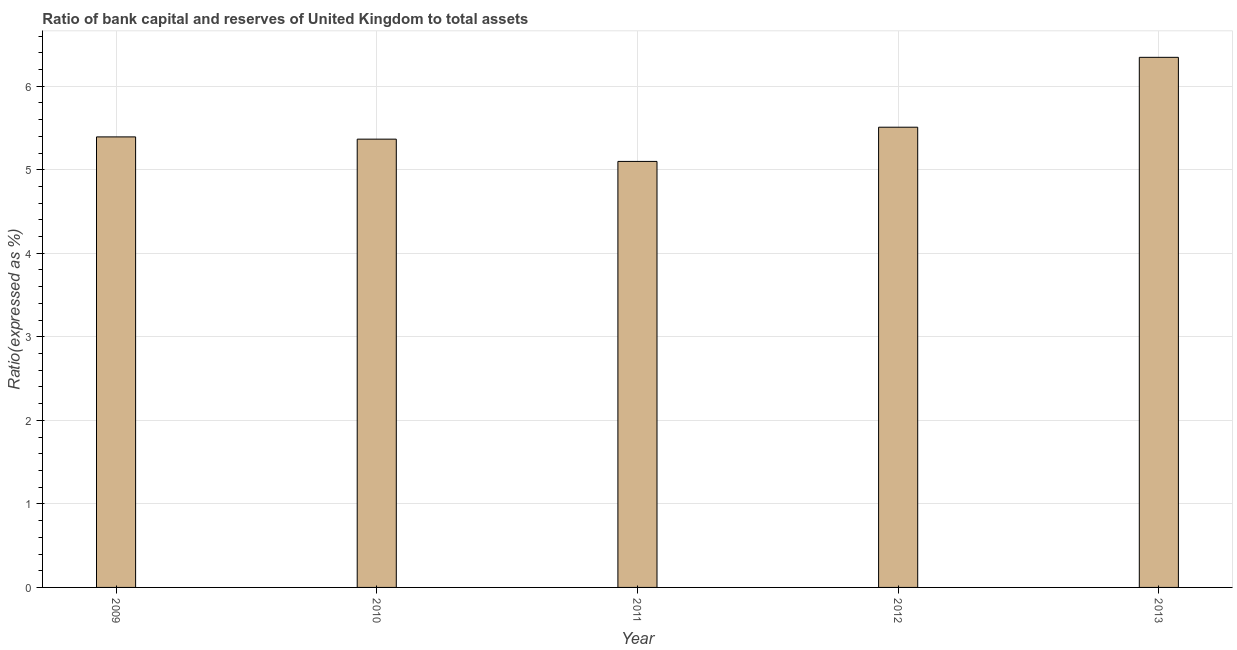What is the title of the graph?
Offer a very short reply. Ratio of bank capital and reserves of United Kingdom to total assets. What is the label or title of the Y-axis?
Provide a succinct answer. Ratio(expressed as %). What is the bank capital to assets ratio in 2013?
Give a very brief answer. 6.35. Across all years, what is the maximum bank capital to assets ratio?
Give a very brief answer. 6.35. Across all years, what is the minimum bank capital to assets ratio?
Your answer should be compact. 5.1. What is the sum of the bank capital to assets ratio?
Offer a very short reply. 27.71. What is the difference between the bank capital to assets ratio in 2011 and 2013?
Keep it short and to the point. -1.25. What is the average bank capital to assets ratio per year?
Ensure brevity in your answer.  5.54. What is the median bank capital to assets ratio?
Offer a terse response. 5.39. Do a majority of the years between 2009 and 2010 (inclusive) have bank capital to assets ratio greater than 5 %?
Offer a terse response. Yes. Is the bank capital to assets ratio in 2011 less than that in 2013?
Offer a very short reply. Yes. Is the difference between the bank capital to assets ratio in 2012 and 2013 greater than the difference between any two years?
Your answer should be compact. No. What is the difference between the highest and the second highest bank capital to assets ratio?
Give a very brief answer. 0.84. Is the sum of the bank capital to assets ratio in 2009 and 2010 greater than the maximum bank capital to assets ratio across all years?
Provide a short and direct response. Yes. What is the difference between the highest and the lowest bank capital to assets ratio?
Your answer should be compact. 1.25. How many bars are there?
Make the answer very short. 5. Are all the bars in the graph horizontal?
Your answer should be compact. No. What is the difference between two consecutive major ticks on the Y-axis?
Offer a very short reply. 1. Are the values on the major ticks of Y-axis written in scientific E-notation?
Your answer should be compact. No. What is the Ratio(expressed as %) of 2009?
Your answer should be compact. 5.39. What is the Ratio(expressed as %) of 2010?
Your response must be concise. 5.37. What is the Ratio(expressed as %) of 2011?
Make the answer very short. 5.1. What is the Ratio(expressed as %) of 2012?
Provide a succinct answer. 5.51. What is the Ratio(expressed as %) of 2013?
Provide a short and direct response. 6.35. What is the difference between the Ratio(expressed as %) in 2009 and 2010?
Offer a terse response. 0.03. What is the difference between the Ratio(expressed as %) in 2009 and 2011?
Make the answer very short. 0.29. What is the difference between the Ratio(expressed as %) in 2009 and 2012?
Make the answer very short. -0.12. What is the difference between the Ratio(expressed as %) in 2009 and 2013?
Offer a very short reply. -0.95. What is the difference between the Ratio(expressed as %) in 2010 and 2011?
Provide a short and direct response. 0.27. What is the difference between the Ratio(expressed as %) in 2010 and 2012?
Your answer should be compact. -0.14. What is the difference between the Ratio(expressed as %) in 2010 and 2013?
Your answer should be very brief. -0.98. What is the difference between the Ratio(expressed as %) in 2011 and 2012?
Provide a short and direct response. -0.41. What is the difference between the Ratio(expressed as %) in 2011 and 2013?
Provide a short and direct response. -1.25. What is the difference between the Ratio(expressed as %) in 2012 and 2013?
Give a very brief answer. -0.84. What is the ratio of the Ratio(expressed as %) in 2009 to that in 2011?
Offer a terse response. 1.06. What is the ratio of the Ratio(expressed as %) in 2009 to that in 2013?
Ensure brevity in your answer.  0.85. What is the ratio of the Ratio(expressed as %) in 2010 to that in 2011?
Ensure brevity in your answer.  1.05. What is the ratio of the Ratio(expressed as %) in 2010 to that in 2013?
Provide a short and direct response. 0.85. What is the ratio of the Ratio(expressed as %) in 2011 to that in 2012?
Ensure brevity in your answer.  0.93. What is the ratio of the Ratio(expressed as %) in 2011 to that in 2013?
Provide a short and direct response. 0.8. What is the ratio of the Ratio(expressed as %) in 2012 to that in 2013?
Keep it short and to the point. 0.87. 